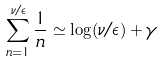Convert formula to latex. <formula><loc_0><loc_0><loc_500><loc_500>\sum _ { n = 1 } ^ { \nu / \epsilon } \frac { 1 } { n } \simeq \log ( \nu / \epsilon ) + \gamma</formula> 